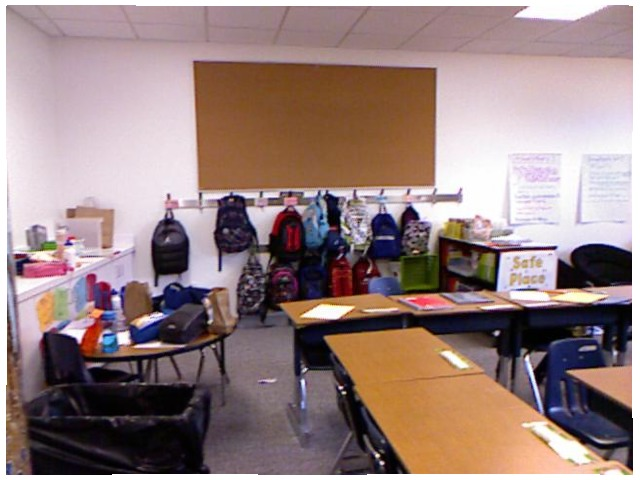<image>
Is the backpack on the wall? Yes. Looking at the image, I can see the backpack is positioned on top of the wall, with the wall providing support. Where is the bag in relation to the bag? Is it on the bag? No. The bag is not positioned on the bag. They may be near each other, but the bag is not supported by or resting on top of the bag. Is there a trash can on the desk? No. The trash can is not positioned on the desk. They may be near each other, but the trash can is not supported by or resting on top of the desk. Where is the water bottle in relation to the lunch bag? Is it under the lunch bag? No. The water bottle is not positioned under the lunch bag. The vertical relationship between these objects is different. 